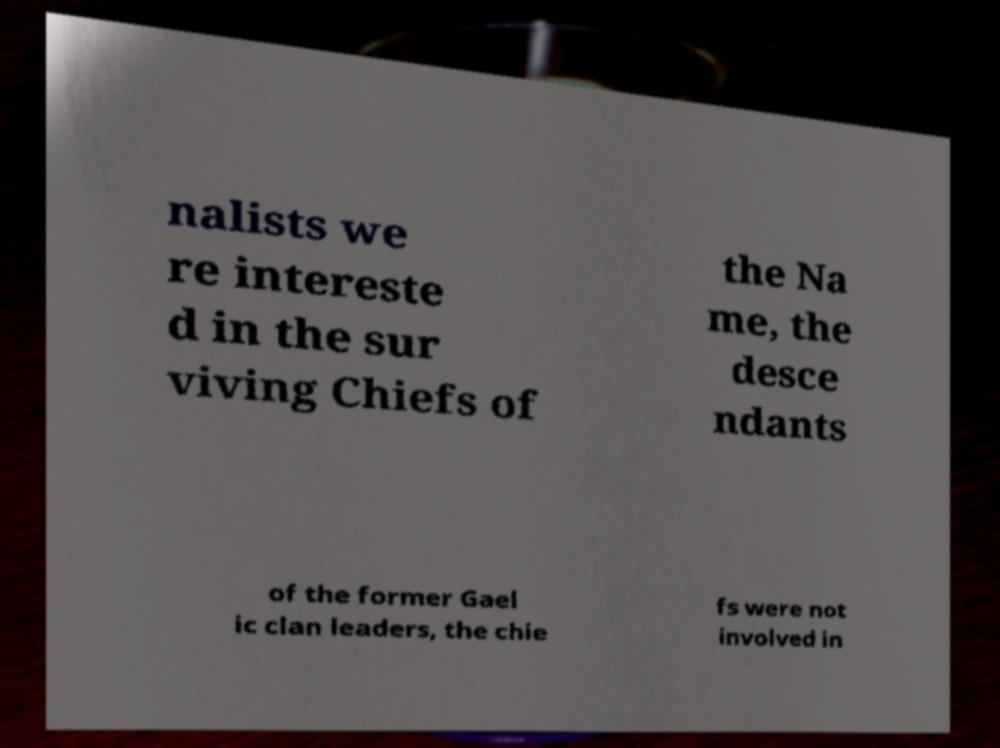For documentation purposes, I need the text within this image transcribed. Could you provide that? nalists we re intereste d in the sur viving Chiefs of the Na me, the desce ndants of the former Gael ic clan leaders, the chie fs were not involved in 